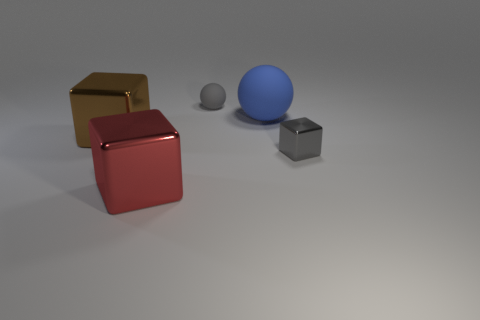Is the brown object to the left of the large sphere made of the same material as the gray sphere?
Offer a very short reply. No. Are there more metallic cubes than small gray metal things?
Give a very brief answer. Yes. Are there any gray cubes behind the large shiny thing that is to the right of the large brown metallic thing?
Offer a very short reply. Yes. There is a tiny shiny object that is the same shape as the big brown thing; what color is it?
Ensure brevity in your answer.  Gray. What is the color of the tiny object that is made of the same material as the large blue sphere?
Your answer should be compact. Gray. There is a tiny gray object that is behind the ball that is on the right side of the tiny rubber object; is there a blue thing that is on the left side of it?
Ensure brevity in your answer.  No. Is the number of metallic things on the right side of the large red thing less than the number of objects right of the tiny gray ball?
Make the answer very short. Yes. How many other things have the same material as the large red thing?
Your answer should be very brief. 2. There is a brown block; is its size the same as the ball that is in front of the gray matte sphere?
Offer a terse response. Yes. There is a small object that is the same color as the tiny rubber ball; what material is it?
Offer a very short reply. Metal. 